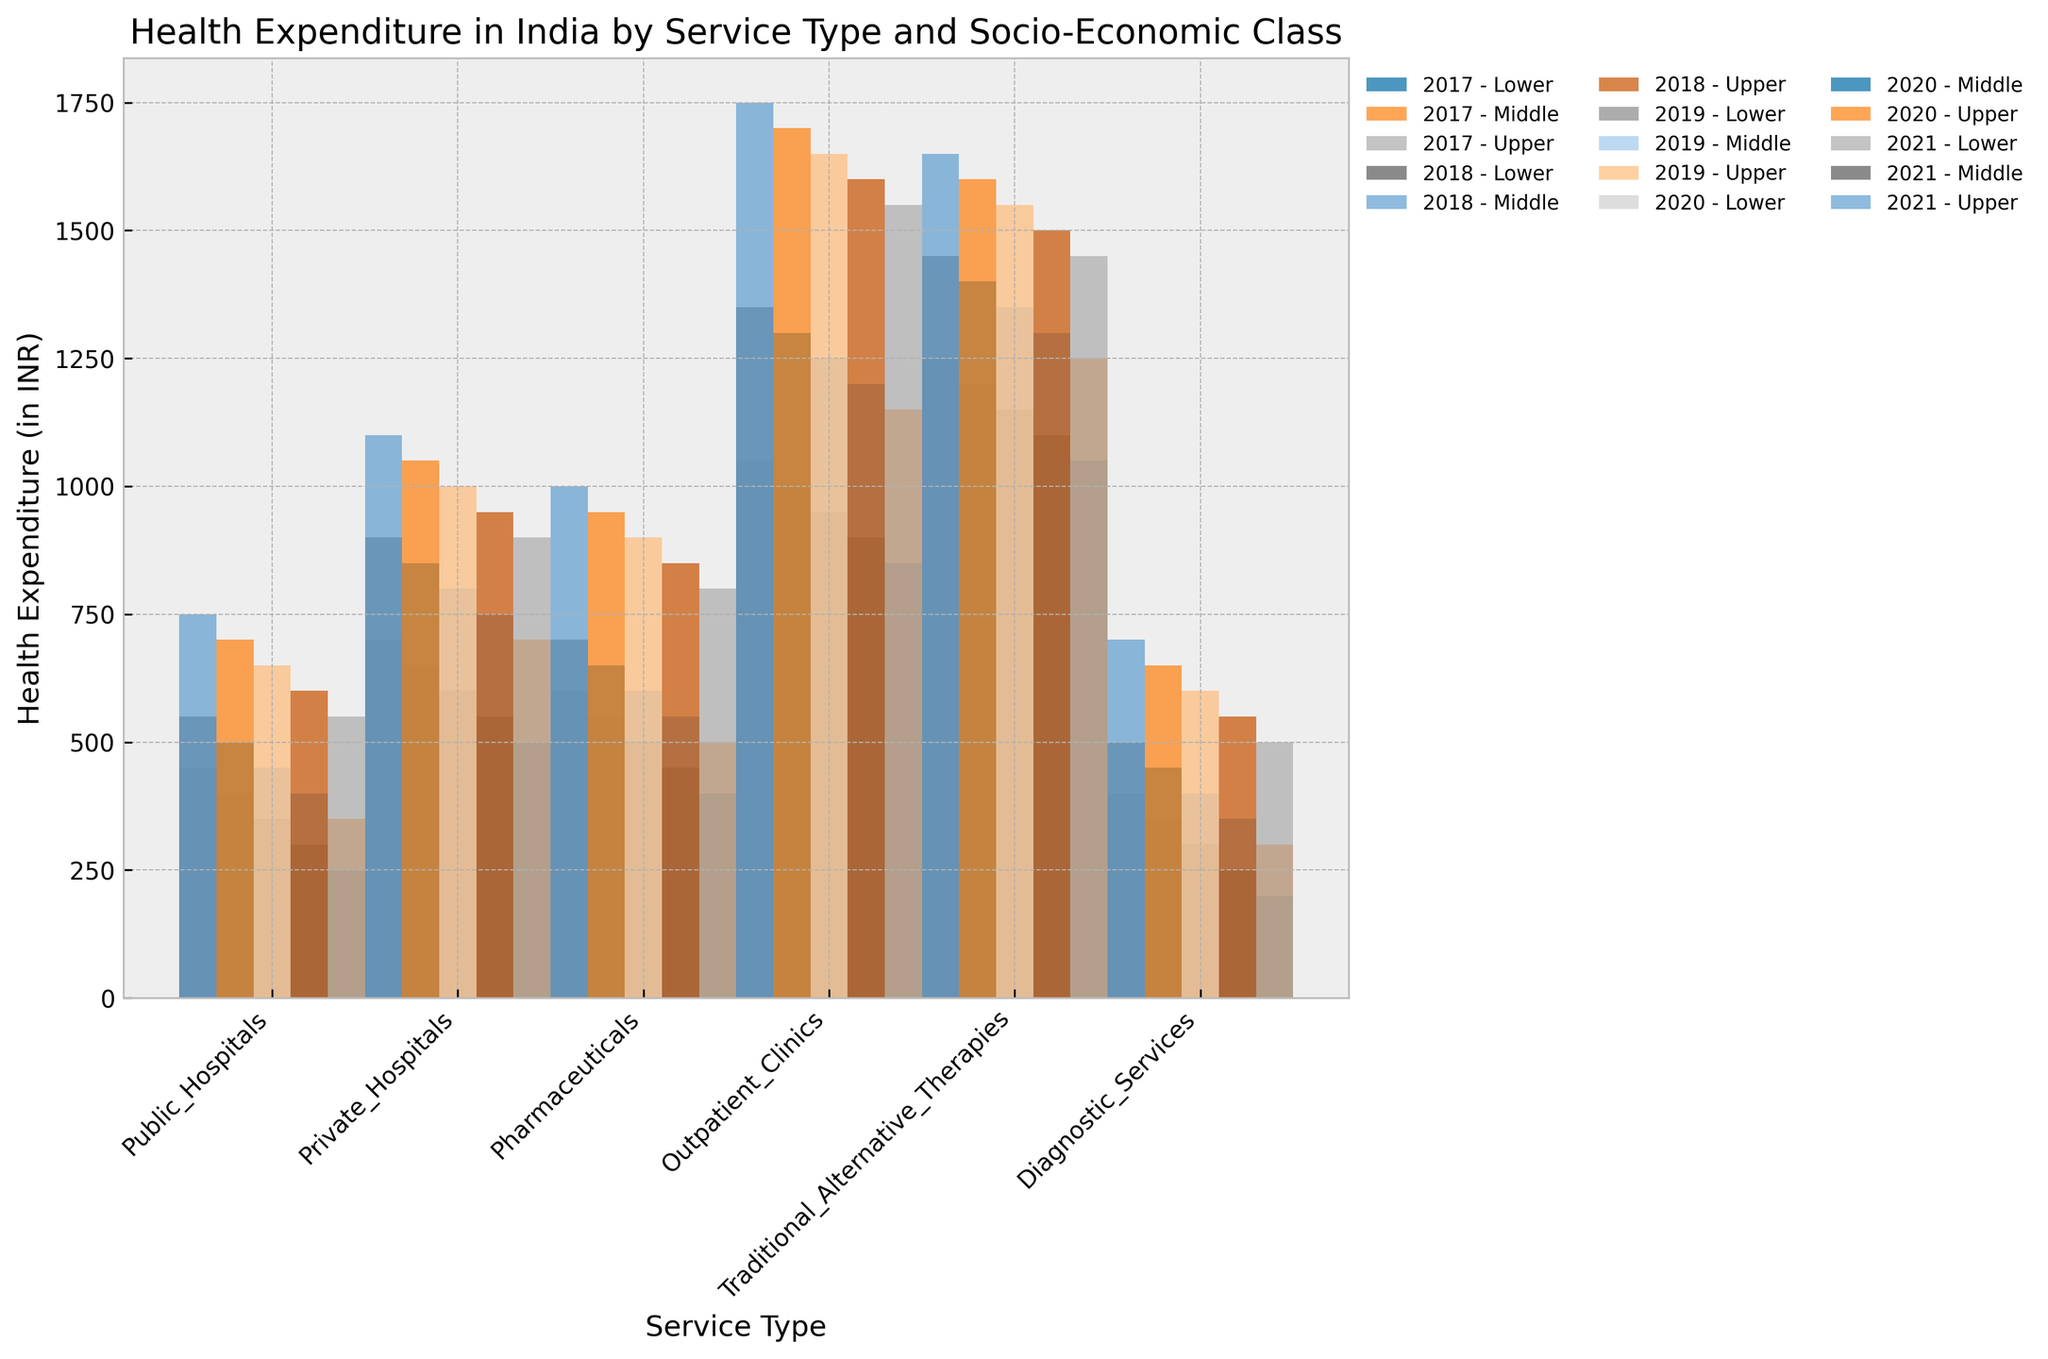How does health expenditure in public hospitals for the lower socio-economic class in 2021 compare to that in 2017? First, locate the bars representing public hospital expenditure for the lower socio-economic class for both 2021 and 2017. In 2017, the expenditure is 1050 INR and in 2021 it increases to 1250 INR. Subtract the earlier value from the later value to find the difference: 1250 - 1050 = 200 INR.
Answer: 200 INR increase Which socio-economic class has the highest expenditure in private hospitals in 2020? Identify all the bars related to private hospitals in 2020 across the lower, middle, and upper socio-economic classes. The expenditures are 1000 INR (lower), 1300 INR (middle), and 1700 INR (upper). The upper class has the highest expenditure.
Answer: Upper class What is the average health expenditure on pharmaceuticals for the middle class across all years? Identify the middle-class bars for pharmaceuticals across all years (500 + 550 + 600 + 650 + 700). Sum these values and then divide by the number of years to find the average: (500 + 550 + 600 + 650 + 700) / 5 = 600 INR.
Answer: 600 INR By how much did health expenditure on diagnostic services increase from 2017 to 2021 for the lower socio-economic class? Locate the bars for diagnostic services for the lower socio-economic class in 2017 and 2021. The values are 250 INR (2017) and 450 INR (2021). Subtract the 2017 value from the 2021 value: 450 - 250 = 200 INR.
Answer: 200 INR What is the total health expenditure on traditional alternative therapies for all socio-economic classes in 2019? Sum the expenditures for all socio-economic classes for traditional alternative therapies in 2019: 300 INR (lower) + 400 INR (middle) + 600 INR (upper) = 1300 INR.
Answer: 1300 INR Which service type had the highest increase in expenditure for the upper socio-economic class between 2017 and 2021? For each service type, compute the increase for the upper socio-economic class between 2017 and 2021. Compare increments: Public Hospitals (1650 - 1450 = 200 INR), Private Hospitals (1750 - 1550 = 200 INR), Pharmaceuticals (1000 - 800 = 200 INR), Outpatient Clinics (1100 - 900 = 200 INR), Traditional Alternative Therapies (700 - 500 = 200 INR), Diagnostic Services (750 - 550 = 200 INR). All have equal increases: 200 INR.
Answer: All service types (200 INR) Which socio-economic class had the least expenditure on outpatient clinics in 2018? Identify the bars for outpatient clinics in 2018: Lower (550 INR), Middle (750 INR), and Upper (950 INR). The lower class had the least expenditure.
Answer: Lower class Compare the health expenditure on pharmaceuticals in 2019 for the lower and upper socio-economic classes. Identify the expenditure on pharmaceuticals for the lower class (500 INR) and upper class (900 INR) in 2019. The upper class spends more by 900 - 500 = 400 INR.
Answer: Upper class spends 400 INR more 